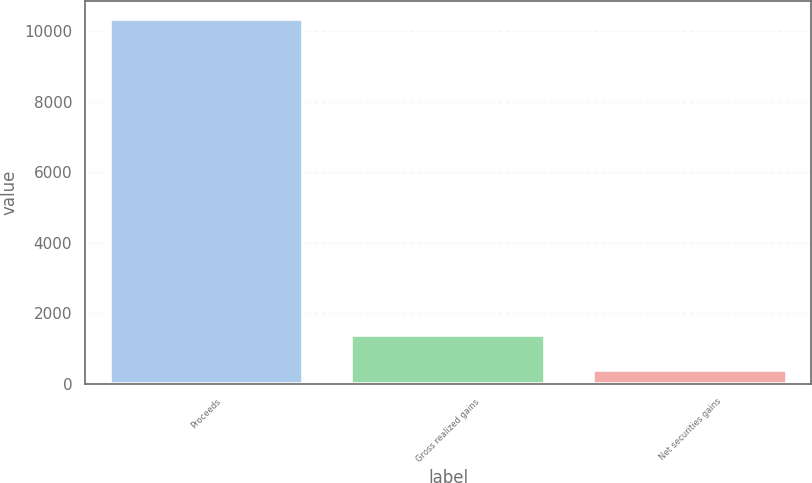Convert chart. <chart><loc_0><loc_0><loc_500><loc_500><bar_chart><fcel>Proceeds<fcel>Gross realized gains<fcel>Net securities gains<nl><fcel>10340<fcel>1388.6<fcel>394<nl></chart> 